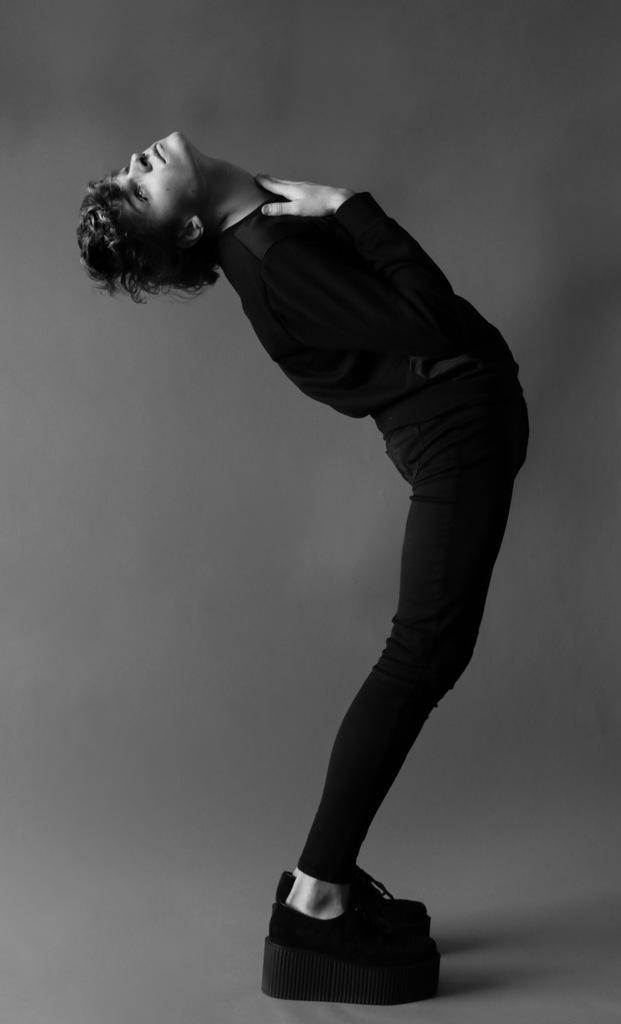What is the color scheme of the image? The image is black and white. Who or what is the main subject in the center of the picture? There is a person in the center of the picture. What is the person wearing? The person is wearing a black dress. How would you describe the background of the image? The background of the image is grey. Can you tell me how many soda cans are visible in the image? There are no soda cans present in the image. Is there an airport visible in the background of the image? There is no airport visible in the image; the background is grey. 